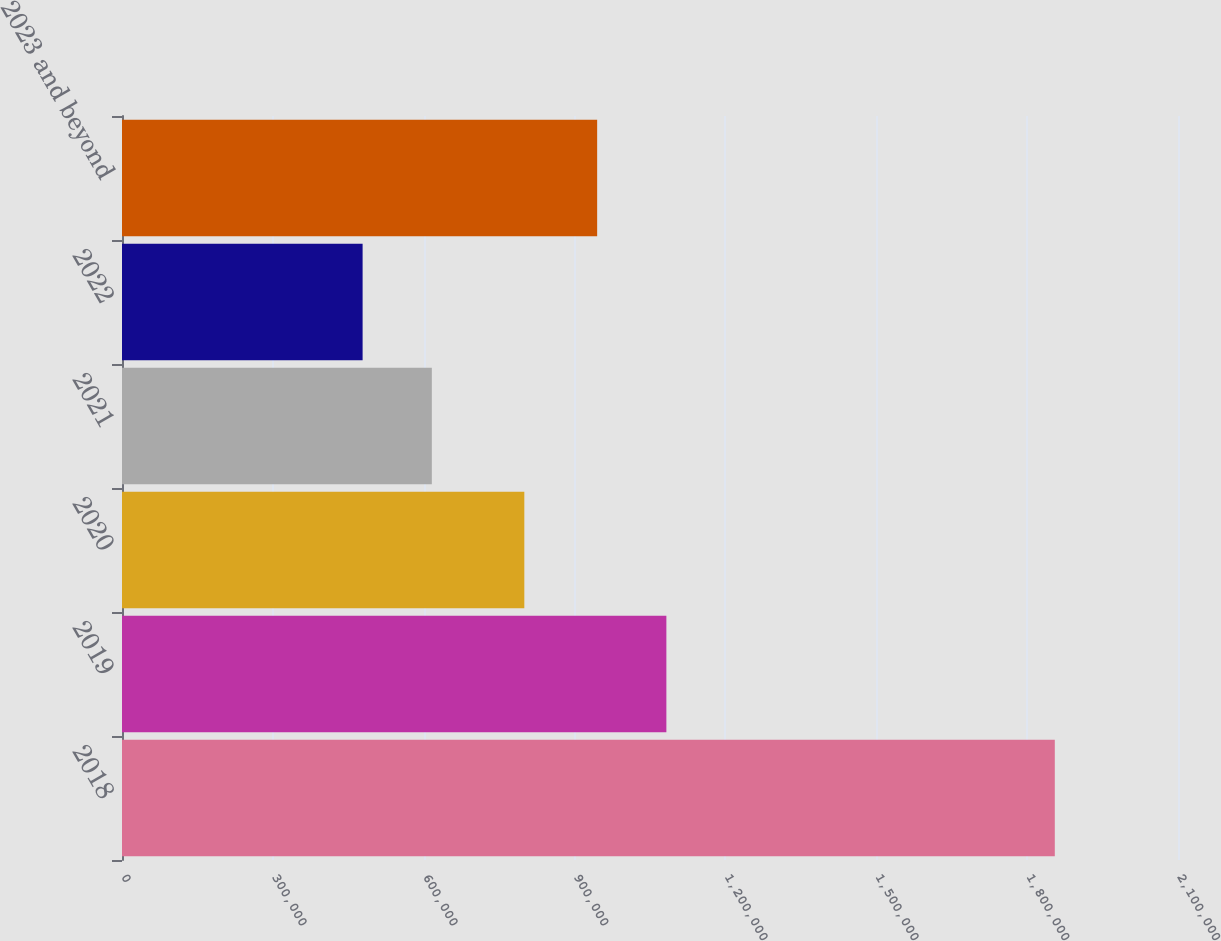Convert chart to OTSL. <chart><loc_0><loc_0><loc_500><loc_500><bar_chart><fcel>2018<fcel>2019<fcel>2020<fcel>2021<fcel>2022<fcel>2023 and beyond<nl><fcel>1.855e+06<fcel>1.08256e+06<fcel>800078<fcel>616132<fcel>478480<fcel>944911<nl></chart> 